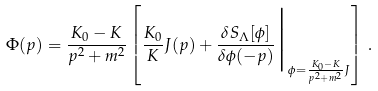<formula> <loc_0><loc_0><loc_500><loc_500>\Phi ( p ) = \frac { K _ { 0 } - K } { p ^ { 2 } + m ^ { 2 } } \left [ \frac { K _ { 0 } } { K } J ( p ) + \frac { \delta S _ { \Lambda } [ \phi ] } { \delta \phi ( - p ) } \Big | _ { \phi = \frac { K _ { 0 } - K } { p ^ { 2 } + m ^ { 2 } } J } \right ] \, .</formula> 